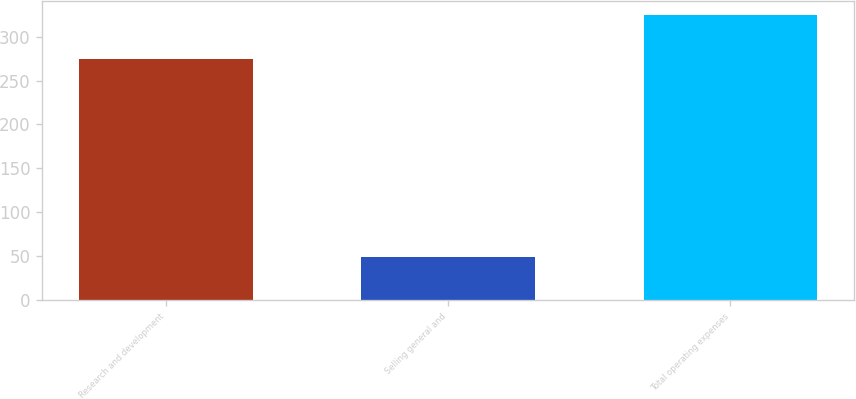<chart> <loc_0><loc_0><loc_500><loc_500><bar_chart><fcel>Research and development<fcel>Selling general and<fcel>Total operating expenses<nl><fcel>274.9<fcel>48.9<fcel>324.7<nl></chart> 